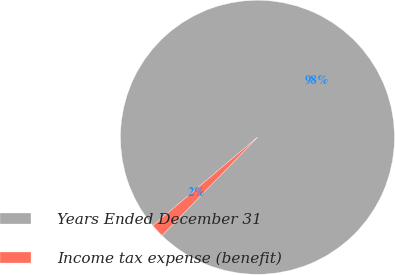Convert chart. <chart><loc_0><loc_0><loc_500><loc_500><pie_chart><fcel>Years Ended December 31<fcel>Income tax expense (benefit)<nl><fcel>98.43%<fcel>1.57%<nl></chart> 